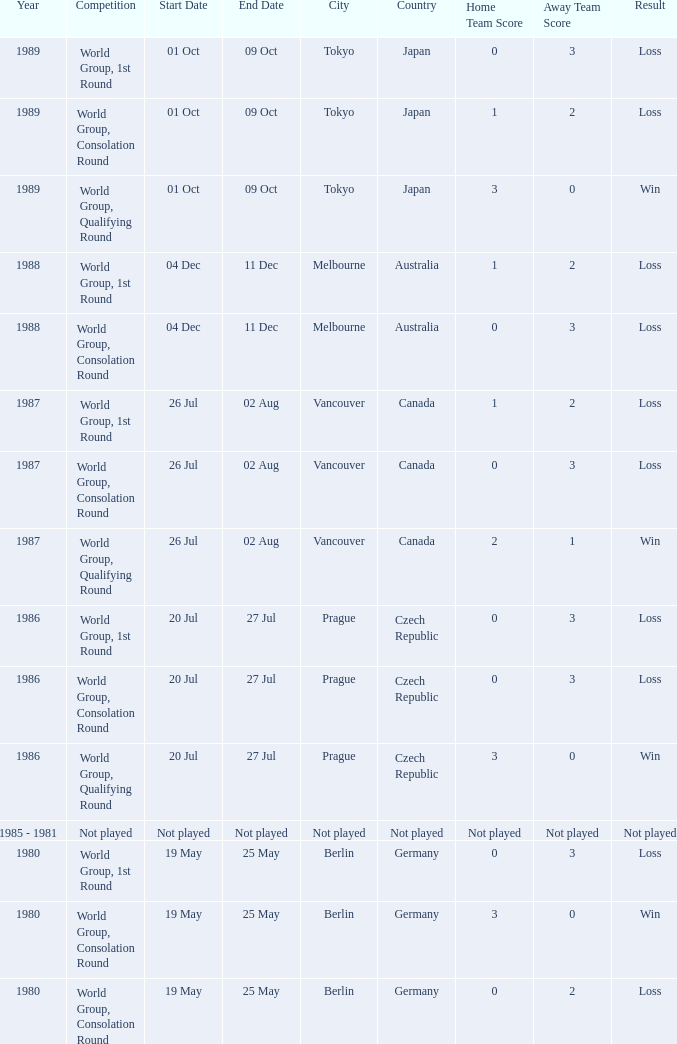What is the date for the game in prague for the world group, consolation round competition? 20 - 27 Jul. 